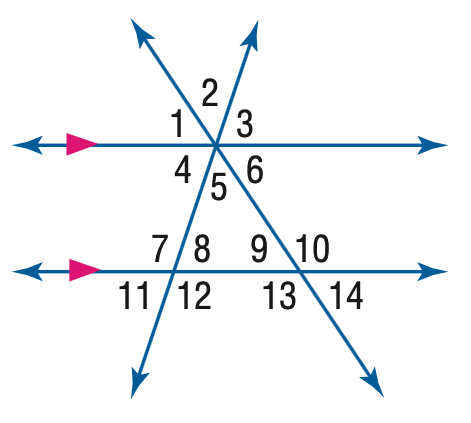Answer the mathemtical geometry problem and directly provide the correct option letter.
Question: In the figure, m \angle 11 = 62 and m \angle 14 = 38. Find the measure of \angle 6.
Choices: A: 38 B: 62 C: 118 D: 142 A 